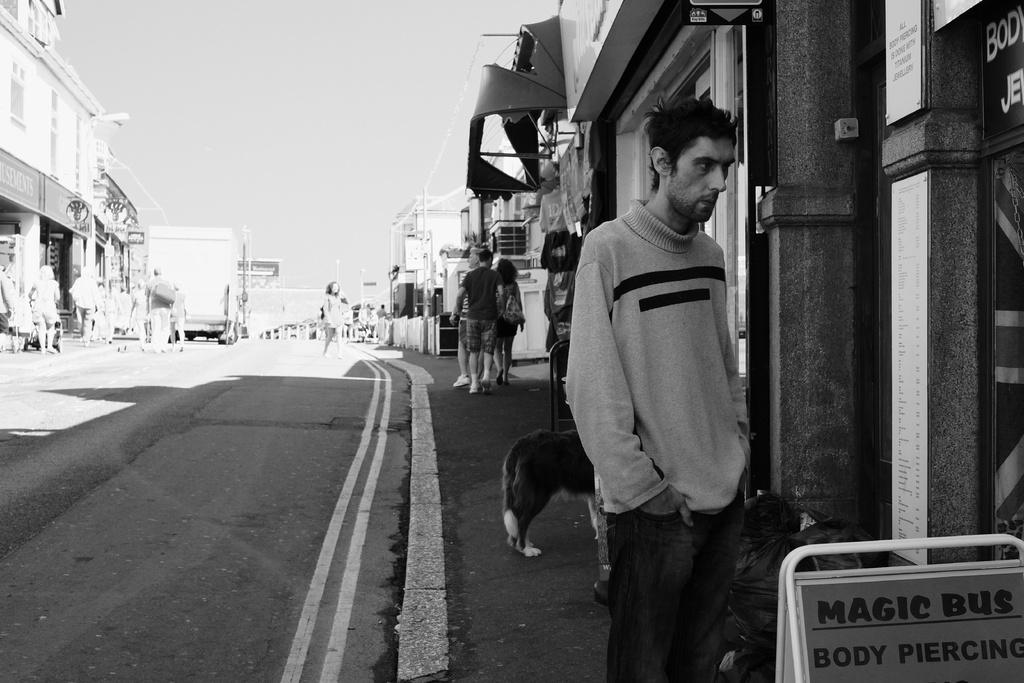What is the color scheme of the image? The image is black and white. What can be seen in the image besides the color scheme? There is a group of people standing, buildings, a road, and boards in the image. What is the background of the image? The sky is visible in the background of the image. Can you tell me how many people are discussing the ocean in the image? There is no discussion about the ocean in the image, nor is there any visible ocean. What type of stop sign can be seen in the image? There is no stop sign present in the image. 